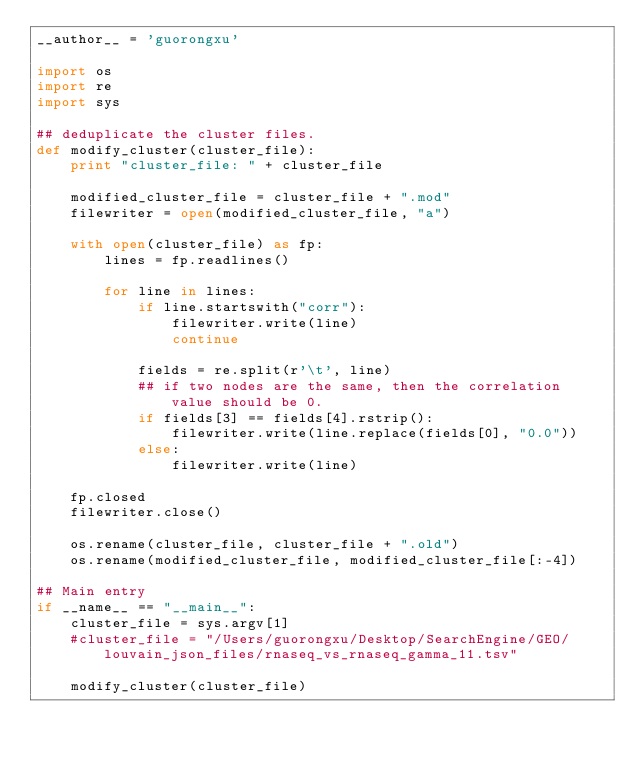Convert code to text. <code><loc_0><loc_0><loc_500><loc_500><_Python_>__author__ = 'guorongxu'

import os
import re
import sys

## deduplicate the cluster files.
def modify_cluster(cluster_file):
    print "cluster_file: " + cluster_file

    modified_cluster_file = cluster_file + ".mod"
    filewriter = open(modified_cluster_file, "a")

    with open(cluster_file) as fp:
        lines = fp.readlines()

        for line in lines:
            if line.startswith("corr"):
                filewriter.write(line)
                continue

            fields = re.split(r'\t', line)
            ## if two nodes are the same, then the correlation value should be 0.
            if fields[3] == fields[4].rstrip():
                filewriter.write(line.replace(fields[0], "0.0"))
            else:
                filewriter.write(line)

    fp.closed
    filewriter.close()

    os.rename(cluster_file, cluster_file + ".old")
    os.rename(modified_cluster_file, modified_cluster_file[:-4])

## Main entry
if __name__ == "__main__":
    cluster_file = sys.argv[1]
    #cluster_file = "/Users/guorongxu/Desktop/SearchEngine/GEO/louvain_json_files/rnaseq_vs_rnaseq_gamma_11.tsv"

    modify_cluster(cluster_file)
</code> 